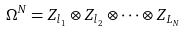Convert formula to latex. <formula><loc_0><loc_0><loc_500><loc_500>\Omega ^ { N } = Z _ { l _ { 1 } } \otimes Z _ { l _ { 2 } } \otimes \cdots \otimes Z _ { L _ { N } }</formula> 